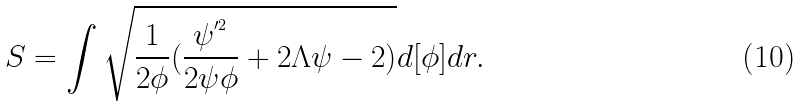Convert formula to latex. <formula><loc_0><loc_0><loc_500><loc_500>S = \int \sqrt { \frac { 1 } { 2 \phi } ( \frac { \psi ^ { ^ { \prime 2 } } } { 2 \psi \phi } + 2 \Lambda \psi - 2 ) } d [ \phi ] d r .</formula> 